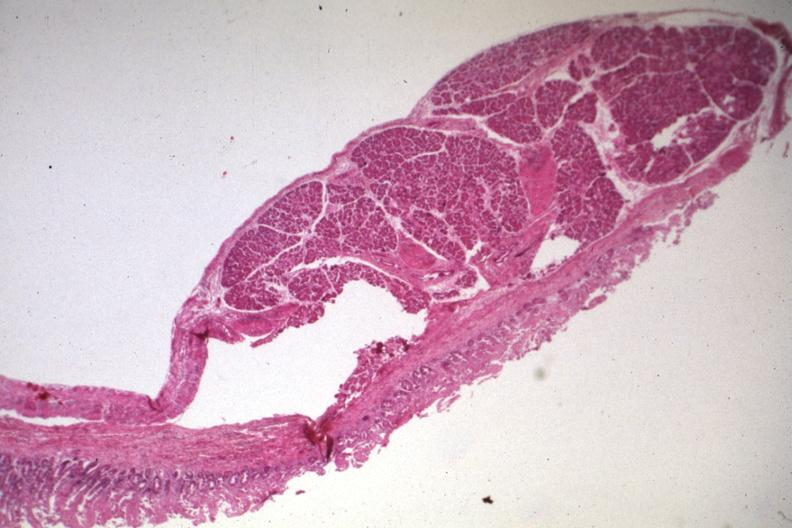does hemorrhage newborn show quite good photo of ectopic pancreas?
Answer the question using a single word or phrase. No 